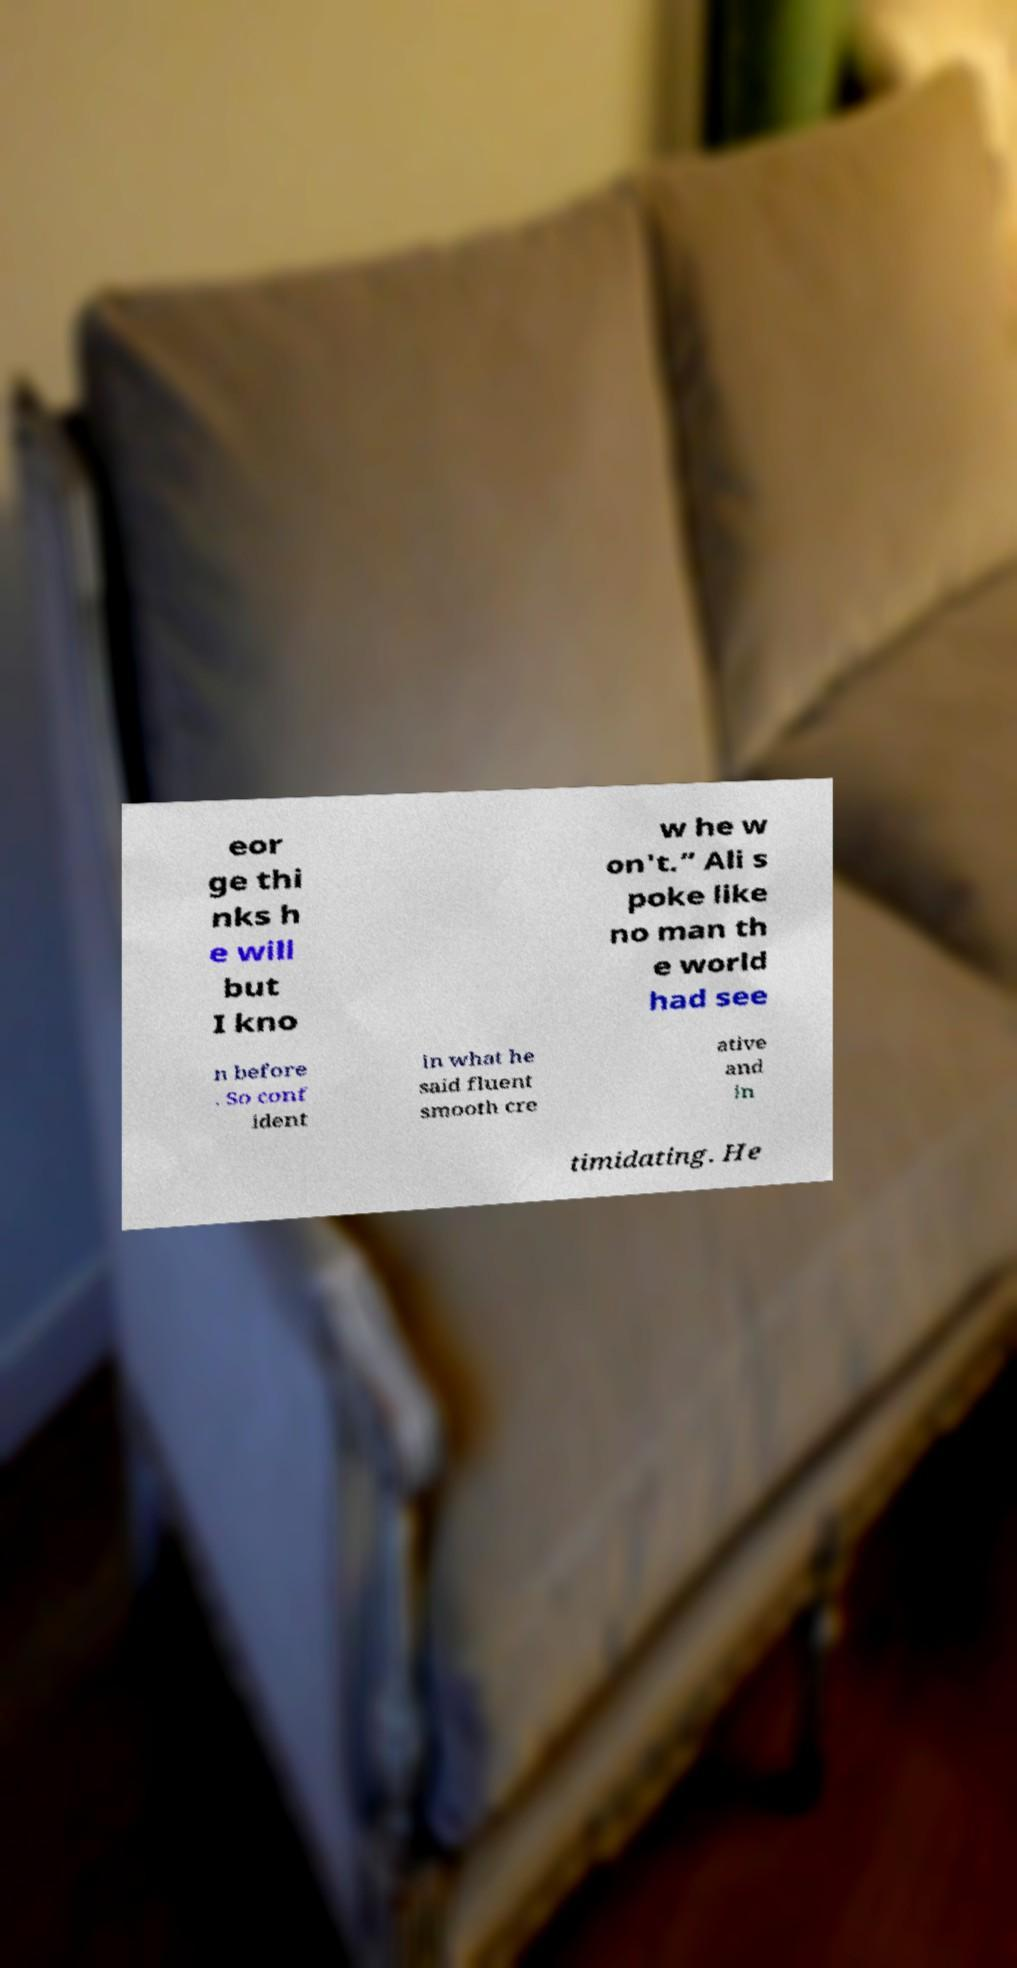Could you extract and type out the text from this image? eor ge thi nks h e will but I kno w he w on't.” Ali s poke like no man th e world had see n before . So conf ident in what he said fluent smooth cre ative and in timidating. He 